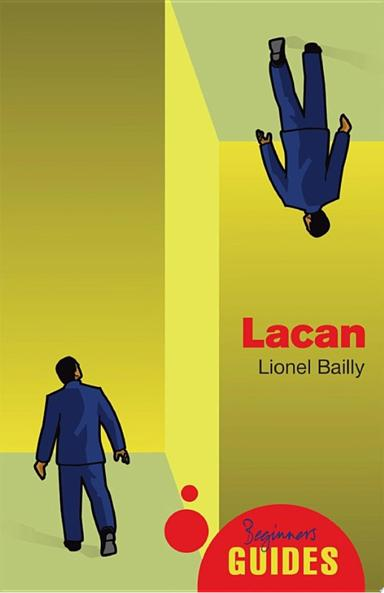Which series is the guide a part of? The guide is a part of the 'Beginner's Guides' series, which aims to provide accessible introductions to complex subjects for newcomers. 